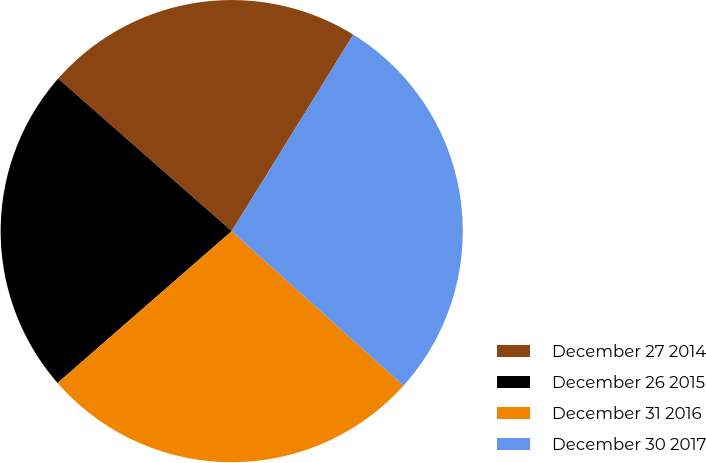Convert chart. <chart><loc_0><loc_0><loc_500><loc_500><pie_chart><fcel>December 27 2014<fcel>December 26 2015<fcel>December 31 2016<fcel>December 30 2017<nl><fcel>22.34%<fcel>22.89%<fcel>26.92%<fcel>27.84%<nl></chart> 